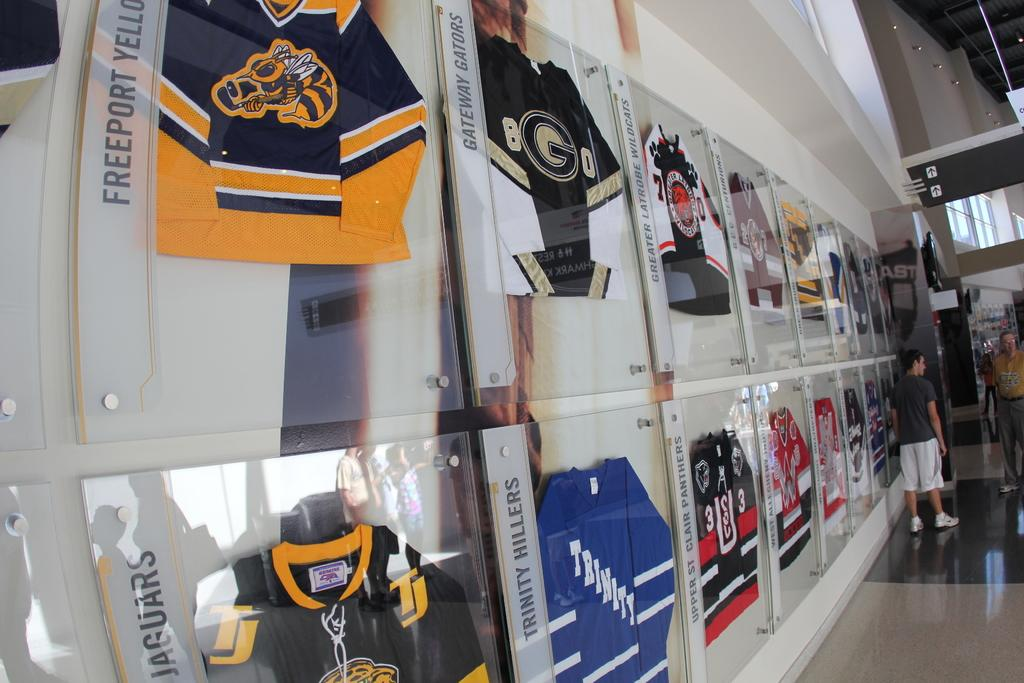Provide a one-sentence caption for the provided image. wall with displays of jerseys for teams such as gateway gators, trinity hillers, and upper st clair panthers. 